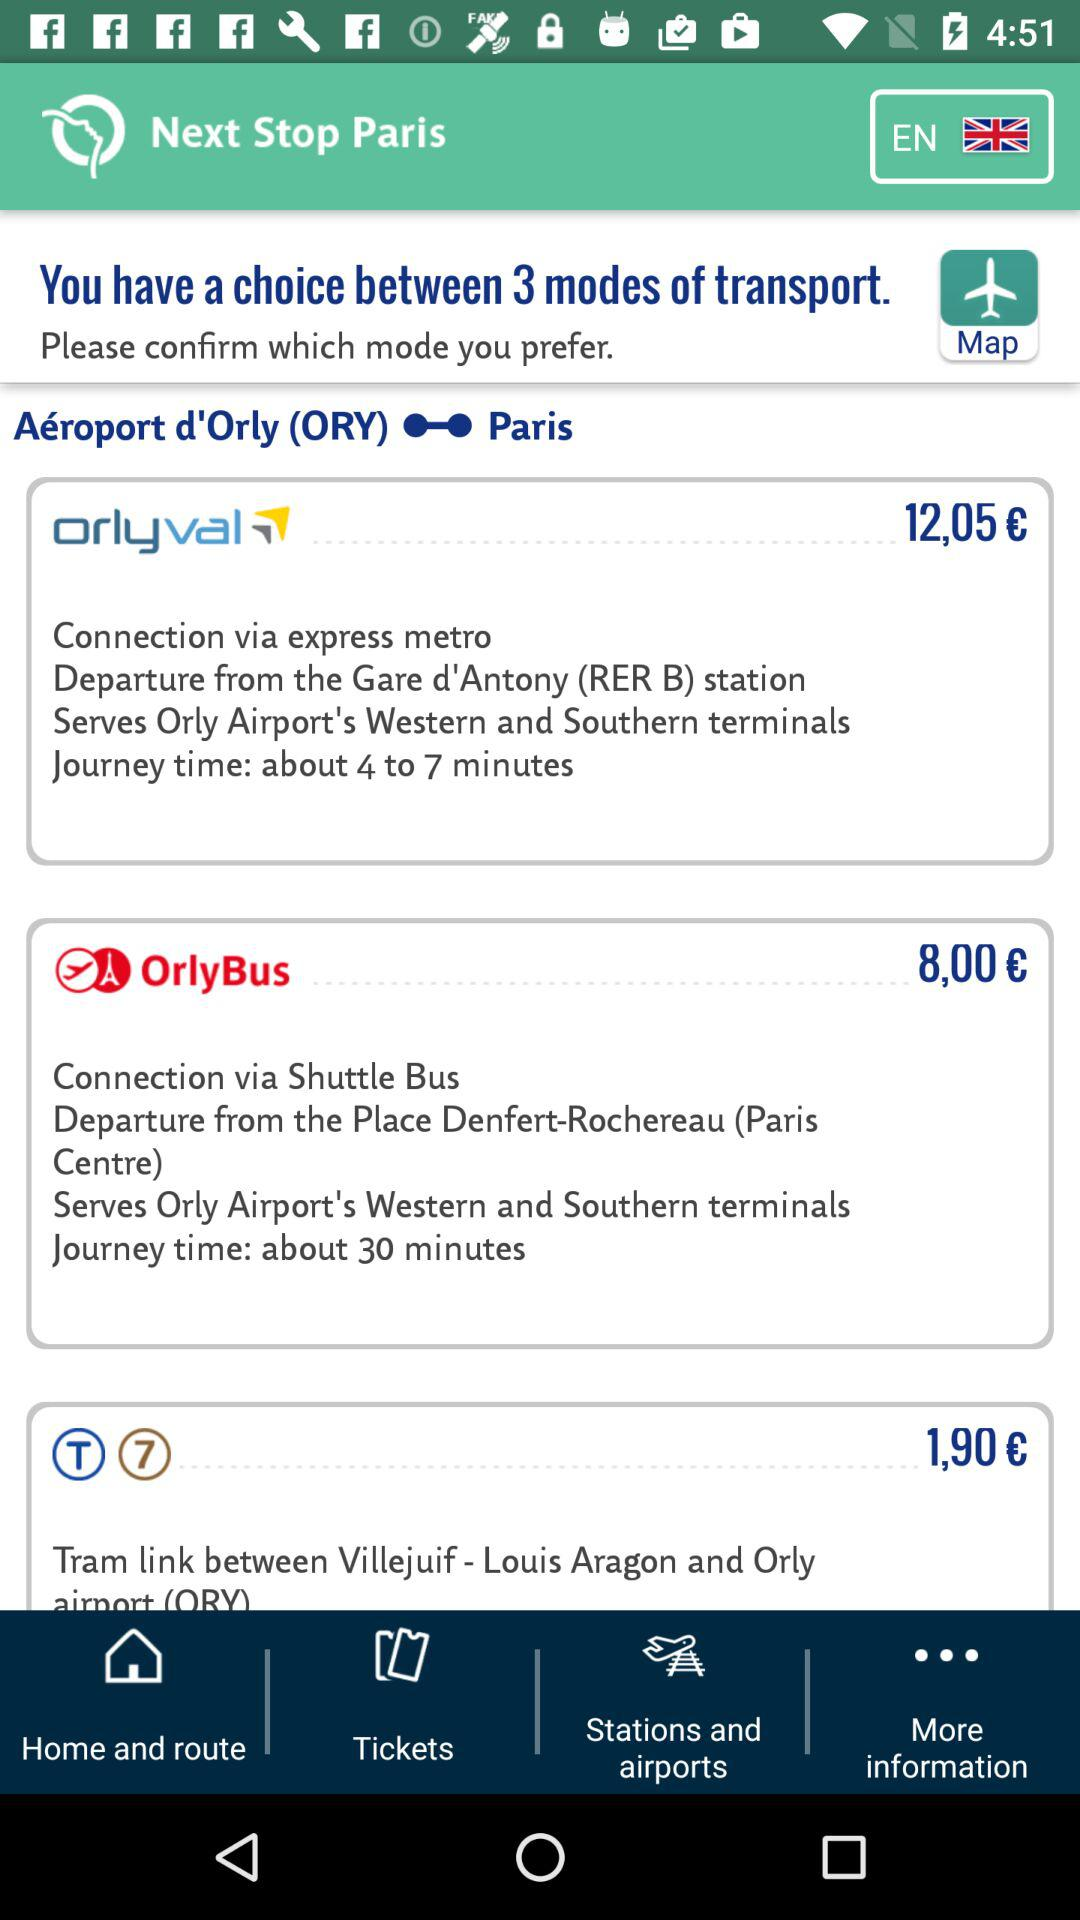What is the transportation cost of OrlyBus? The cost of OrlyBus transportation is 8,00 €. 